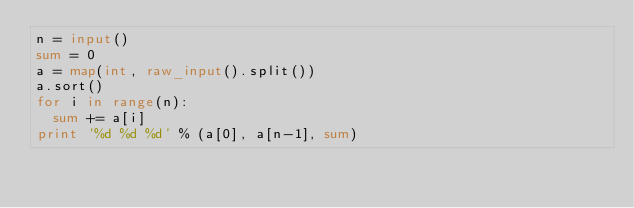<code> <loc_0><loc_0><loc_500><loc_500><_Python_>n = input()
sum = 0
a = map(int, raw_input().split())
a.sort()
for i in range(n):
  sum += a[i]
print '%d %d %d' % (a[0], a[n-1], sum)</code> 